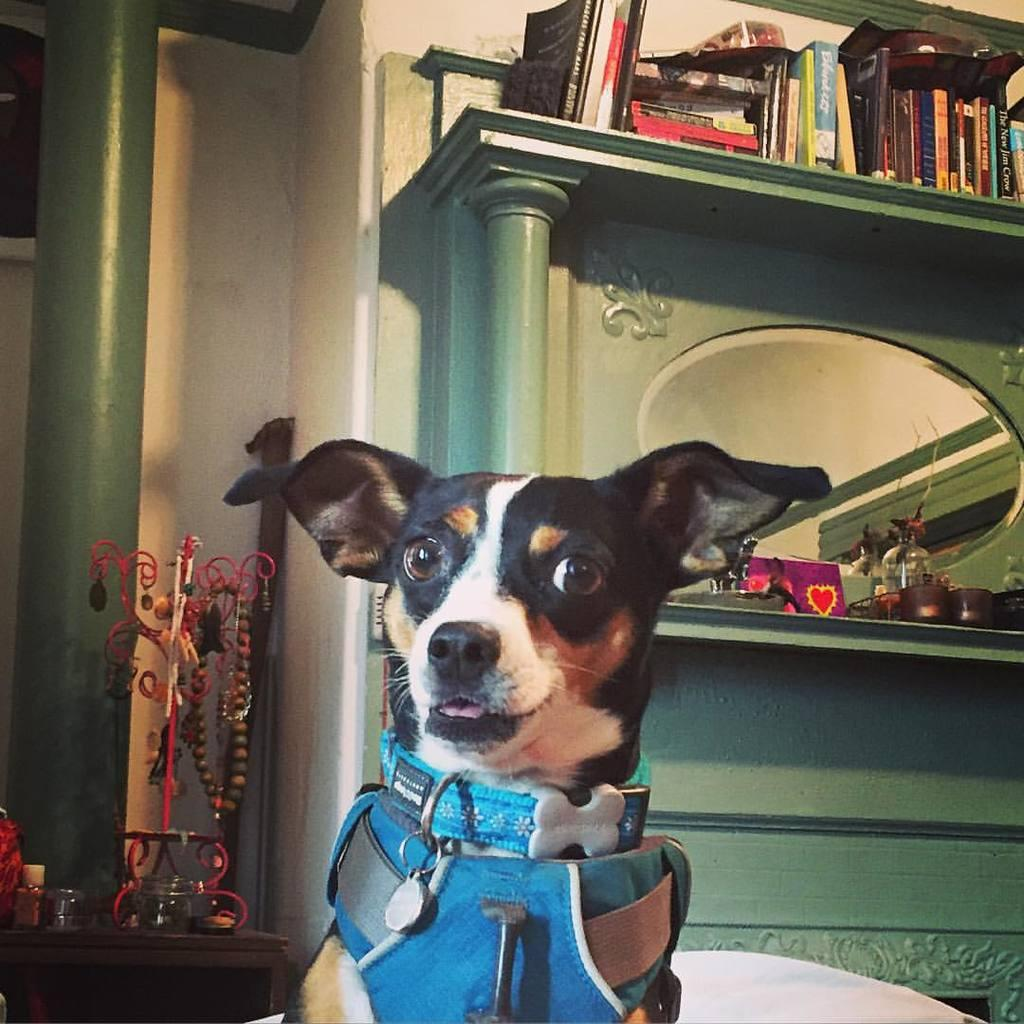What type of animal is present in the image? There is a dog in the image. What furniture or surface can be seen in the image? There is a table and a wooden shelf in the image. What architectural feature is visible in the image? There is a pillar in the image. How many pieces of cheese are on the wooden shelf in the image? There is no cheese present on the wooden shelf in the image. What type of seafood can be seen on the table in the image? There is no seafood, such as clams, present on the table in the image. 